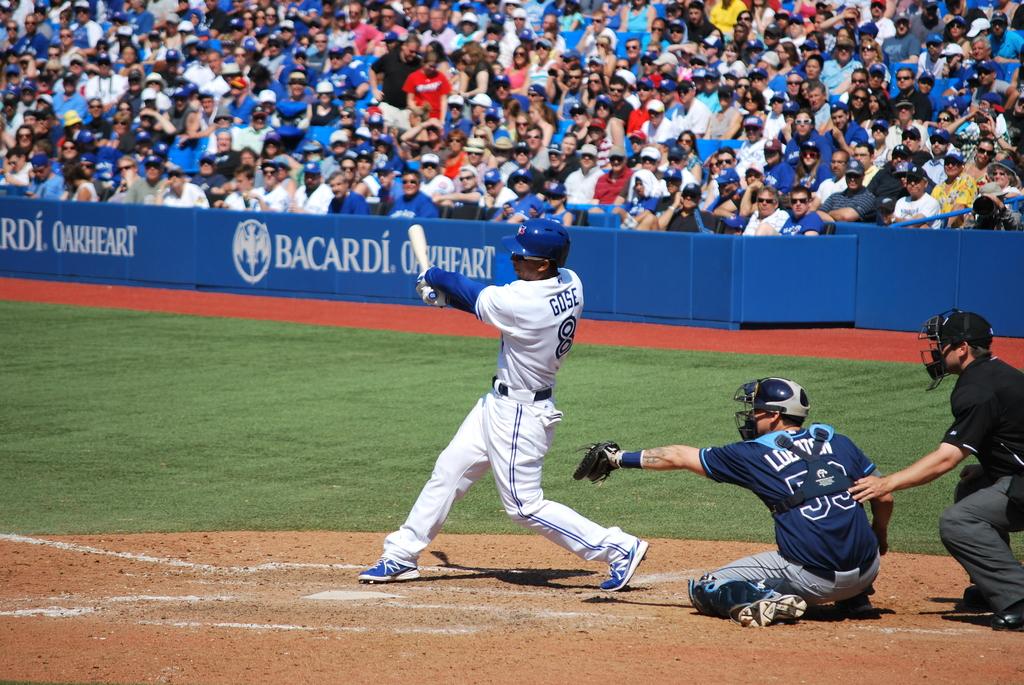What is the sign on the stand?
Offer a very short reply. Bacardi oakheart. 